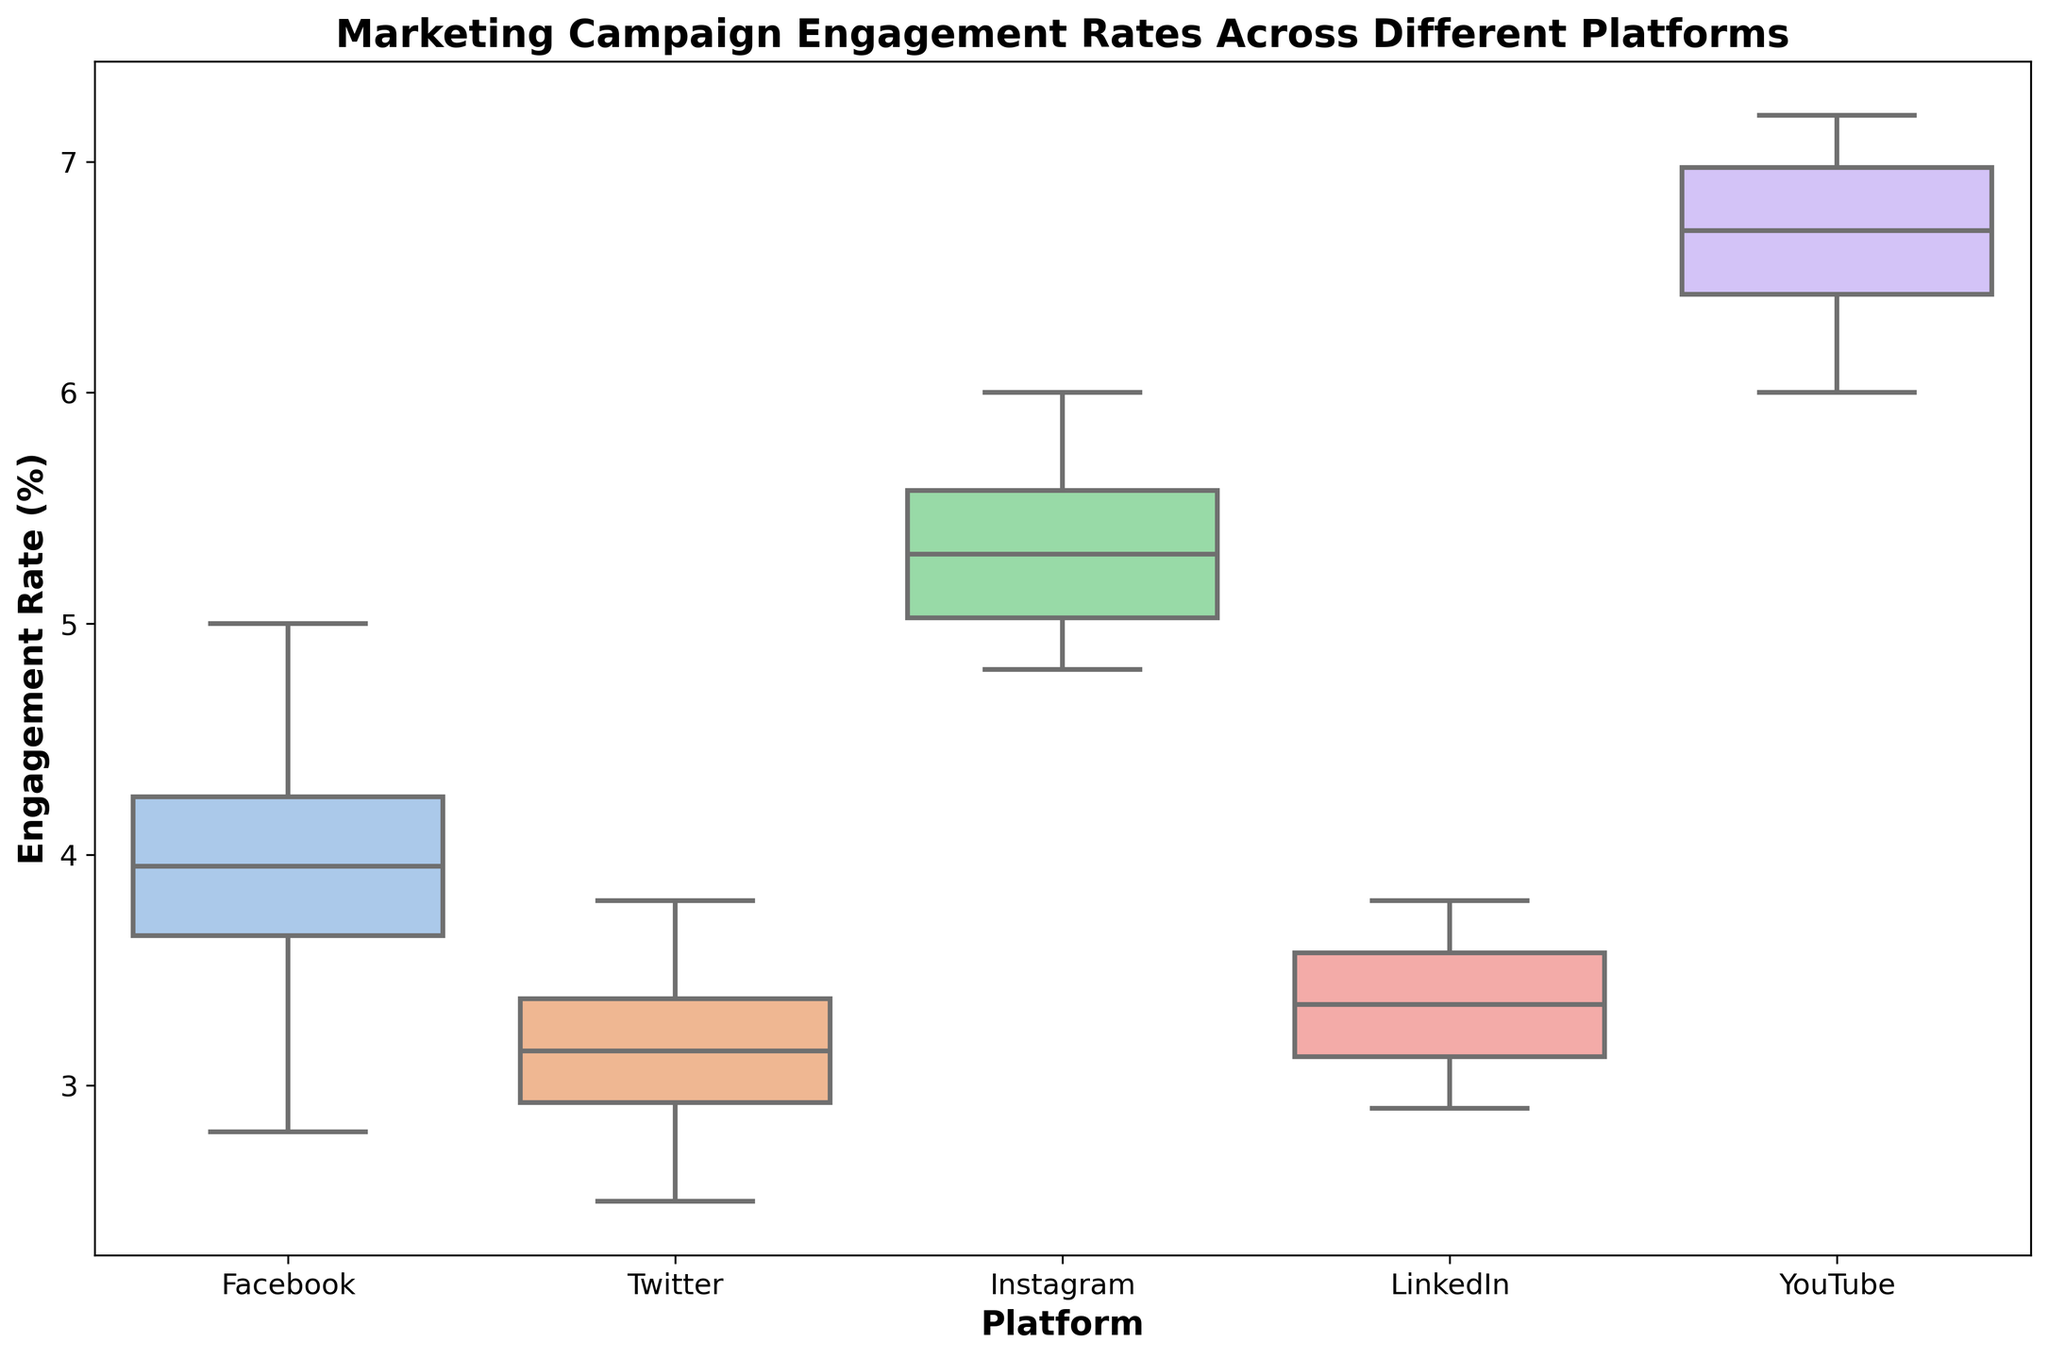What's the median engagement rate for Instagram? The median is the middle value of a data set when it’s ordered. For Instagram, the ordered data set is [4.8, 4.9, 5.0, 5.1, 5.2, 5.4, 5.5, 5.6, 5.8, 6.0]. The median is the average of the 5th and 6th values: (5.2 + 5.4) / 2 = 5.3.
Answer: 5.3 Which platform has the highest median engagement rate? Highest median engagement rate is found by comparing the central line of each boxplot from all platforms. YouTube has the highest median line.
Answer: YouTube What is the interquartile range (IQR) for Facebook's engagement rate? IQR is calculated by subtracting the 25th percentile (Q1) from the 75th percentile (Q3). For Facebook, Q1 is approximately 3.6 and Q3 is approximately 4.3, so IQR is 4.3 - 3.6 = 0.7.
Answer: 0.7 Compare the spread of engagement rates between Twitter and LinkedIn. The spread (range) is observed by the length of respective boxplots. Twitter and LinkedIn have similar spreads, but LinkedIn's boxplot appears slightly narrower indicating less variability.
Answer: LinkedIn has less variability Which platform shows the greatest variability in engagement rates? Variability is represented by the size of the boxplot and the length of the whiskers. YouTube has the largest spread from minimum to maximum values, indicating the greatest variability.
Answer: YouTube How does the median engagement rate of LinkedIn compare to Twitter? Comparing median lines of LinkedIn and Twitter boxplots shows that LinkedIn’s median line is slightly higher than Twitter's.
Answer: LinkedIn's median is higher What are the maximum and minimum engagement rates observed on Instagram? The maximum and minimum are observed as the highest and lowest whisker points on Instagram’s boxplot. They are approximately 6.0 and 4.8, respectively.
Answer: Max: 6.0, Min: 4.8 Which platform has the smallest interquartile range (IQR)? The smallest IQR is seen by comparing the widths of the boxes. LinkedIn’s box is the narrowest, indicating the smallest IQR.
Answer: LinkedIn What is the median engagement rate for Facebook relative to the overall range of YouTube? The median engagement rate for Facebook can be found by locating the middle line of its boxplot, which is around 4. The overall range of YouTube is from approximately 6 to 7.2. Facebook's median (4.0) is outside YouTube's overall range.
Answer: Outside YouTube's range Compare the lower quartile (25th percentile) values between Instagram and YouTube. Locate the bottom of the boxes representing Q1 for both platforms. Instagram’s Q1 is roughly around 5.0 while YouTube’s Q1 is approximately 6.3.
Answer: Instagram's Q1 is lower 